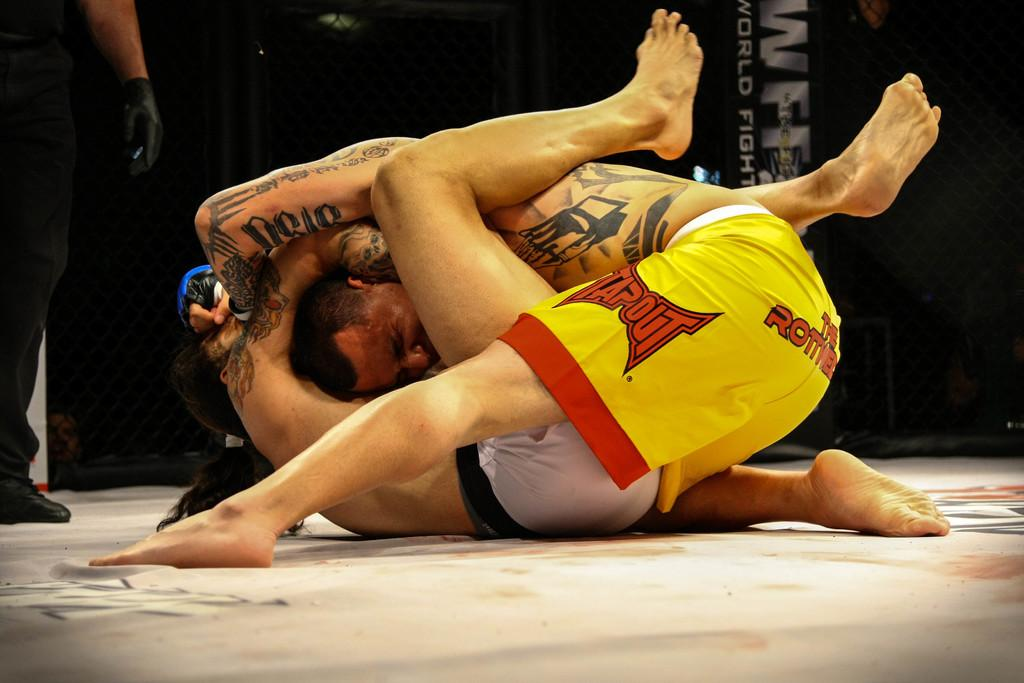<image>
Create a compact narrative representing the image presented. The Tapout logo can be seen on a guy wrestling with another guy on a mat. 